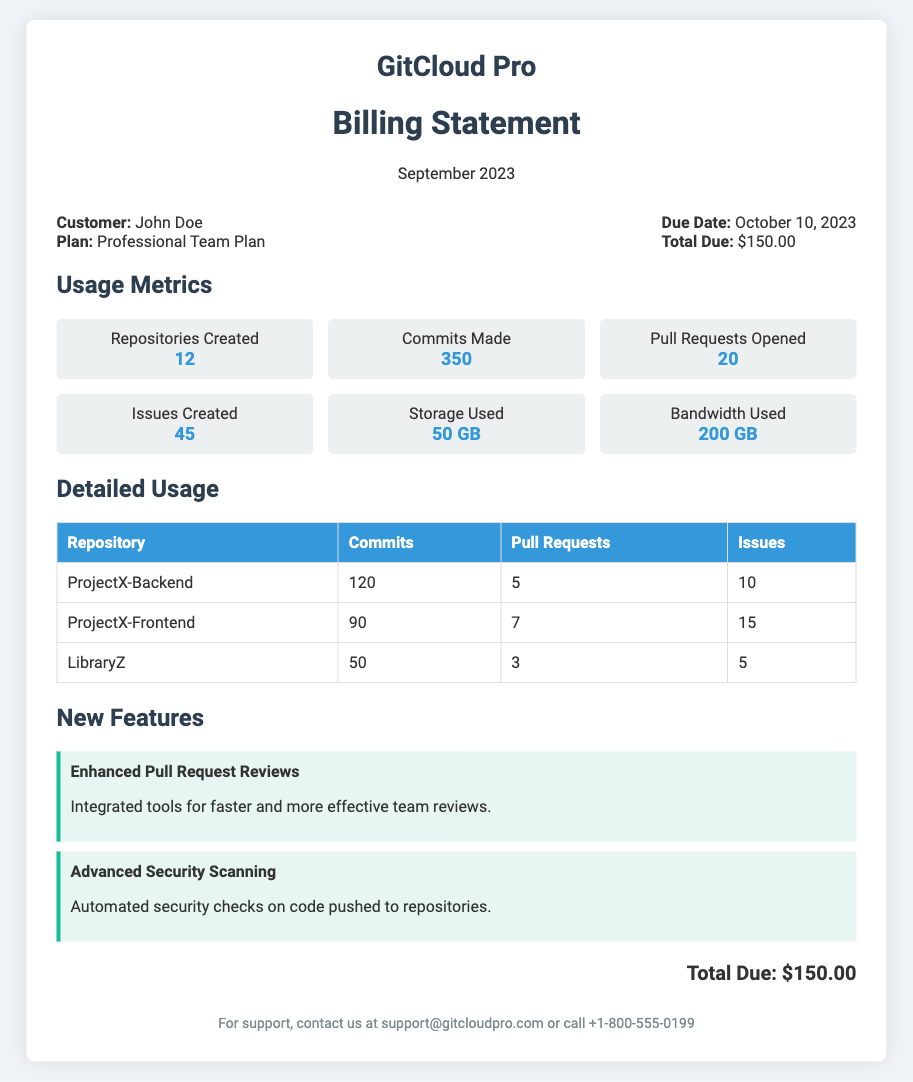What is the name of the customer? The customer's name is mentioned in the billing info section as John Doe.
Answer: John Doe What is the total due amount? The total amount due is stated clearly at the end of the billing info section.
Answer: $150.00 How many repositories were created? The usage metrics section specifies the number of repositories created during the billing period.
Answer: 12 What new feature was added for security? The new features section describes the addition of advanced security checks, specifically mentioned as automated security checks.
Answer: Advanced Security Scanning How many pull requests were opened? The usage metrics section gives the total number of pull requests opened in September 2023.
Answer: 20 What is the storage used during the billing period? The usage metrics indicate the amount of storage utilized by the customer during the billing period.
Answer: 50 GB Which project had the highest number of commits? The detailed usage table lists the number of commits for each project, allowing identification of which had the most commits.
Answer: ProjectX-Backend How many issues were created in ProjectX-Frontend? The detailed usage table specifies the number of issues created in ProjectX-Frontend.
Answer: 15 When is the due date for payment? The due date for payment is provided in the billing info section.
Answer: October 10, 2023 